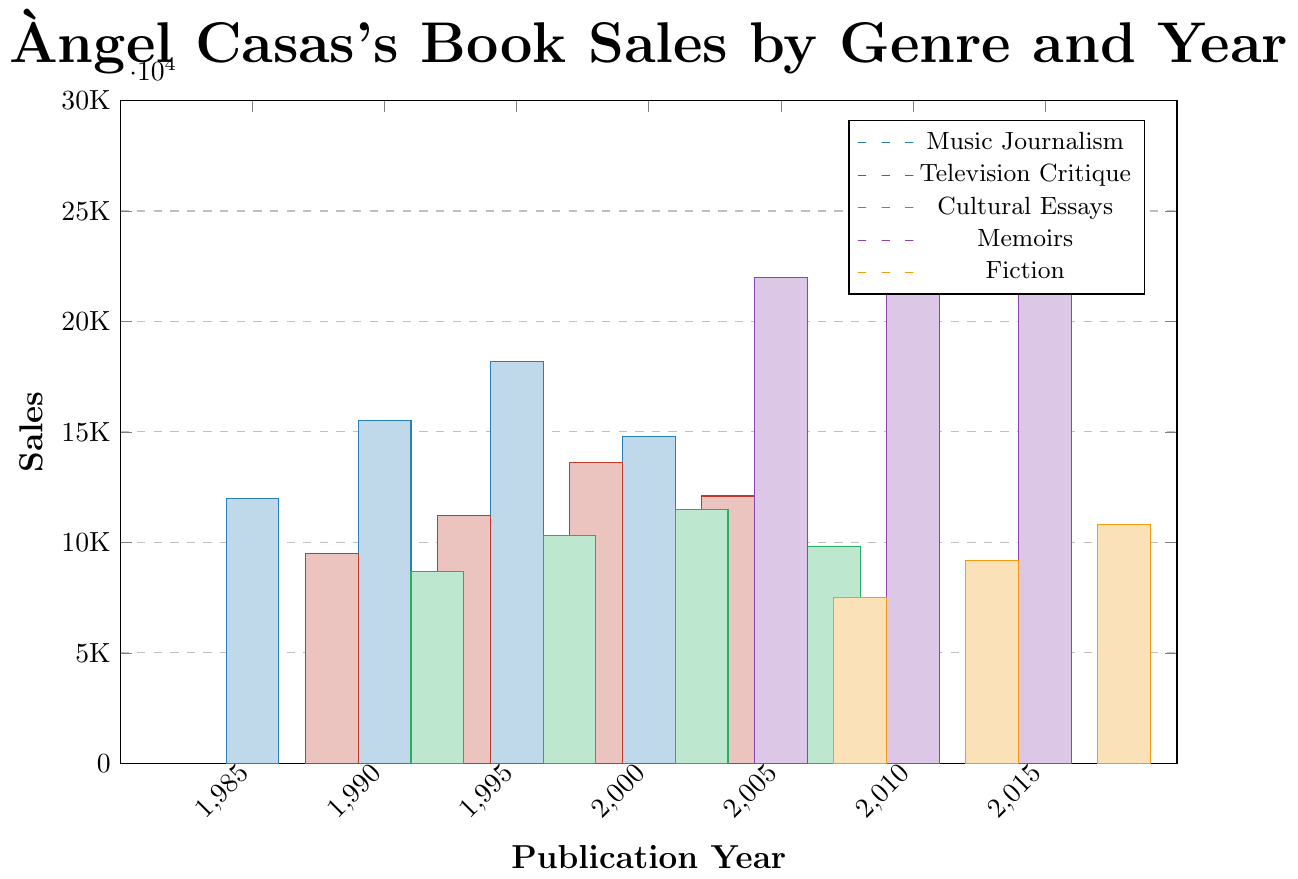What was the total book sales in the year 1998? To find the total sales in 1998, add the sales of each genre for that year, which includes Television Critique (13600).
Answer: 13600 Which genre had the highest sales in the year 2015? Compare the sales of each genre in 2015. Only the Memoirs genre has data for 2015, with sales of 28300.
Answer: Memoirs What was the difference in sales between Music Journalism in 2000 and Fiction in 2008? Subtract the sales of Fiction in 2008 (7500) from the sales of Music Journalism in 2000 (14800): 14800 - 7500 = 7300.
Answer: 7300 Which genre had the lowest sales in the year 2007? Compare the sales of each genre in 2007. Only Cultural Essays had data for 2007, with sales of 9800.
Answer: Cultural Essays What is the average sales figure for Memoirs across all years in the dataset? To find the average sales for Memoirs, add the sales figures for 2005 (22000), 2010 (25600), and 2015 (28300), then divide by the number of years (3). (22000 + 25600 + 28300) / 3 = 25300.
Answer: 25300 In which year did Cultural Essays reach their highest sales? Compare the sales data for Cultural Essays across the years (1992, 1997, 2002, 2007). The highest sales were in 2002 with 11500.
Answer: 2002 Which genre and year had sales closest to 10000? Compare all sales figures to 10000. The closest value is Cultural Essays in 1997, which had sales of 10300.
Answer: Cultural Essays, 1997 What are the combined sales of Television Critique and Fiction in 2018? Add the sales figures for Television Critique and Fiction in 2018. Only Fiction has data for 2018, with sales of 10800 and Television Critique has no data for 2018. Thus, the combined sales are only from Fiction.
Answer: 10800 How do the sales of Music Journalism in 1995 compare to Memoirs in 2010? Compare the sales figures directly: Music Journalism in 1995 has 18200, whereas Memoirs in 2010 has 25600. Memoirs in 2010 had higher sales.
Answer: Memoirs in 2010 had higher sales Across all years, which genre shows the most consistent increase in sales? Tracking across years, Memoirs consistently increases from 2005 (22000) to 2010 (25600) to 2015 (28300).
Answer: Memoirs 